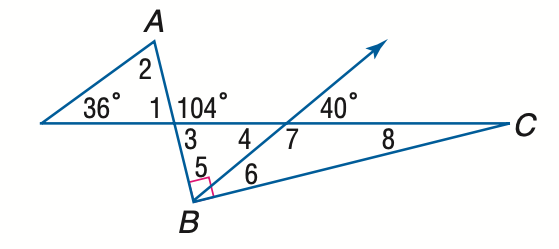Answer the mathemtical geometry problem and directly provide the correct option letter.
Question: Find the measure of \angle 1 if A B \perp B C.
Choices: A: 64 B: 68 C: 72 D: 76 D 